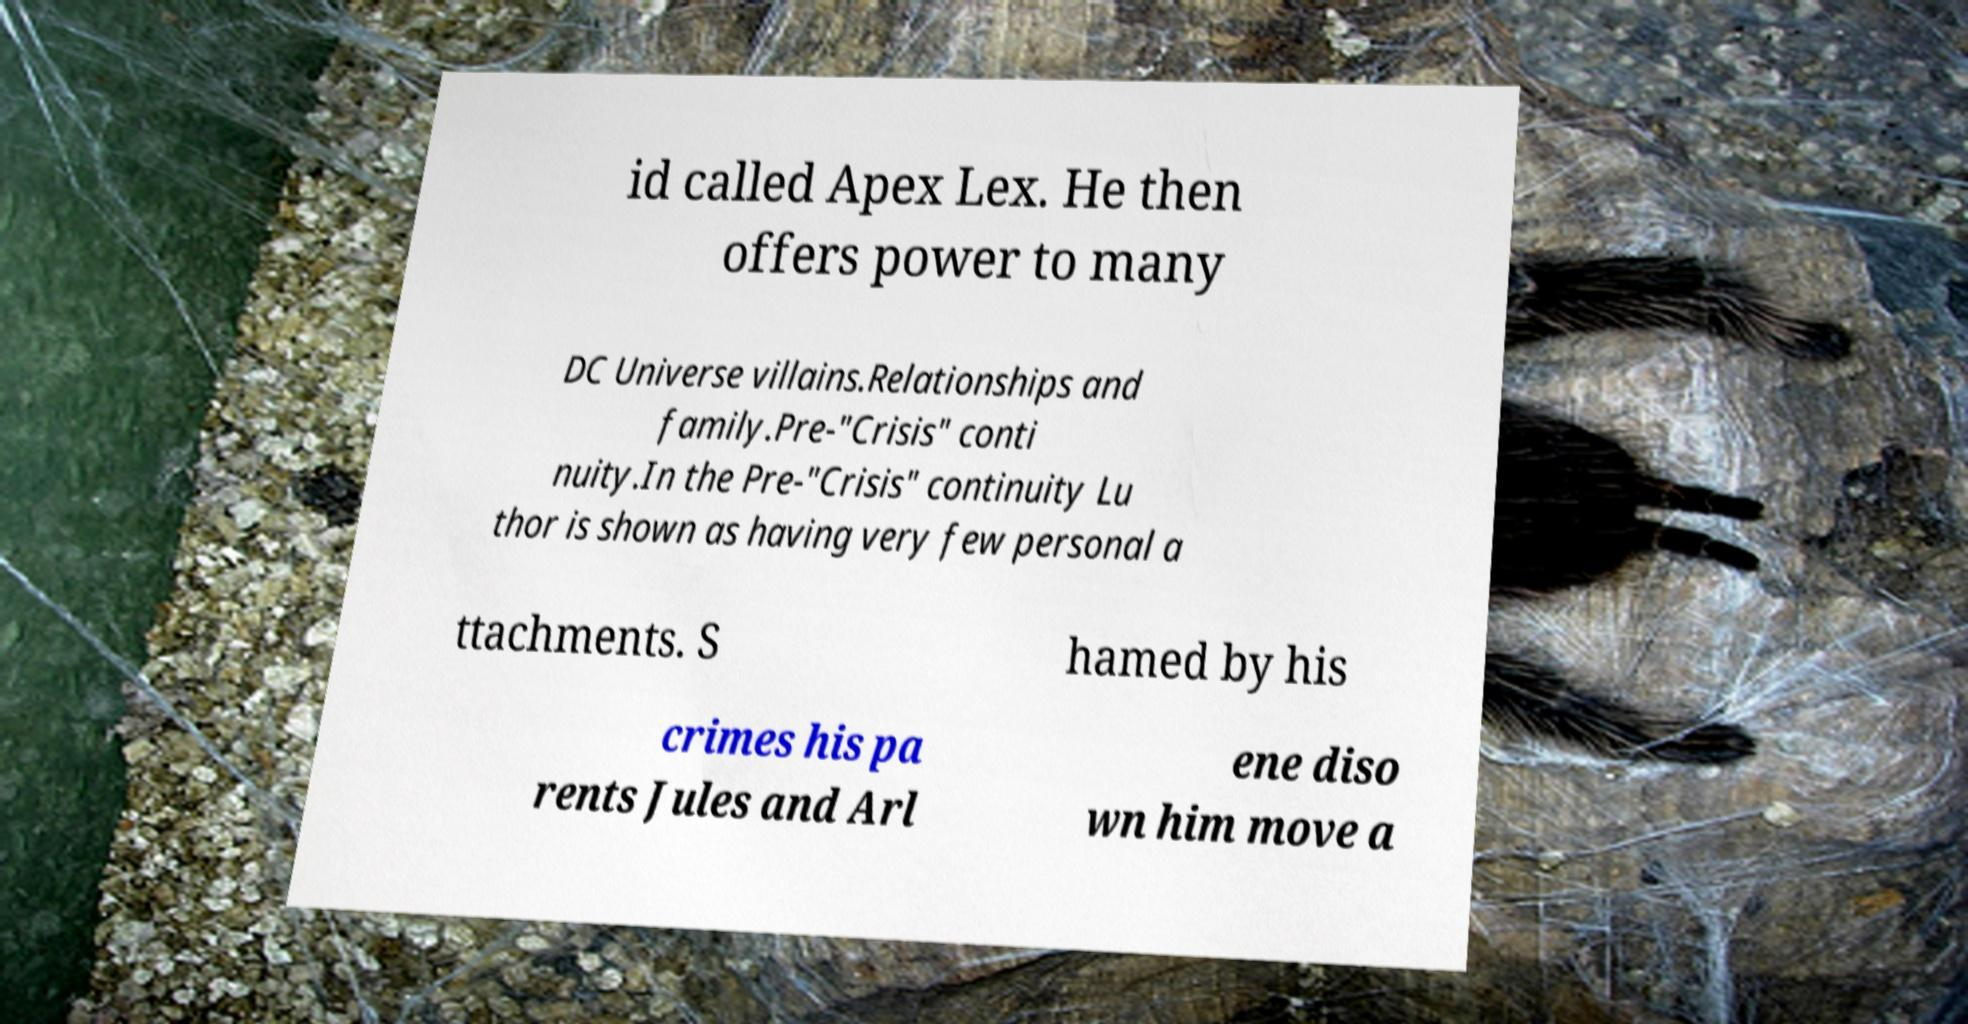Could you assist in decoding the text presented in this image and type it out clearly? id called Apex Lex. He then offers power to many DC Universe villains.Relationships and family.Pre-"Crisis" conti nuity.In the Pre-"Crisis" continuity Lu thor is shown as having very few personal a ttachments. S hamed by his crimes his pa rents Jules and Arl ene diso wn him move a 